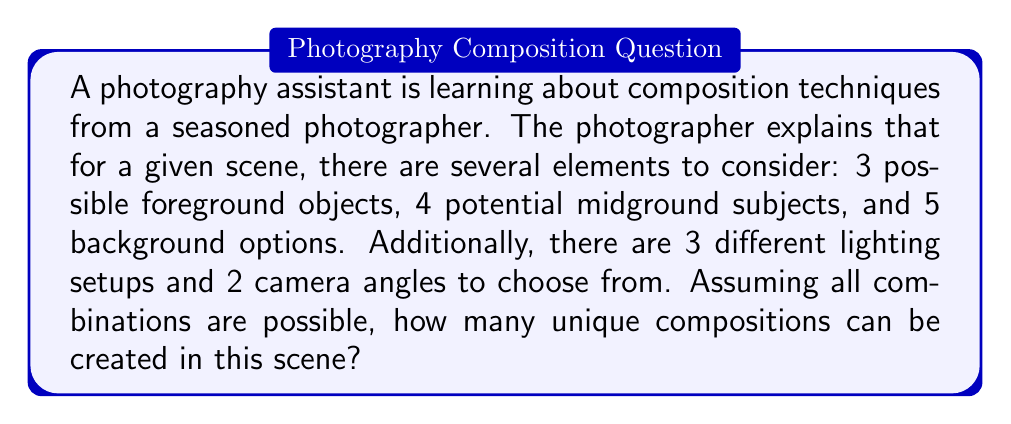What is the answer to this math problem? To solve this problem, we'll use the multiplication principle of counting. This principle states that if we have independent choices, we multiply the number of options for each choice to get the total number of possible combinations.

Let's break down the elements:

1. Foreground objects: 3 options
2. Midground subjects: 4 options
3. Background options: 5 options
4. Lighting setups: 3 options
5. Camera angles: 2 options

To calculate the total number of unique compositions, we multiply these numbers together:

$$ \text{Total compositions} = 3 \times 4 \times 5 \times 3 \times 2 $$

Let's calculate step by step:

$$ \begin{align*}
\text{Total compositions} &= 3 \times 4 \times 5 \times 3 \times 2 \\
&= 12 \times 5 \times 3 \times 2 \\
&= 60 \times 3 \times 2 \\
&= 180 \times 2 \\
&= 360
\end{align*} $$

Therefore, there are 360 possible unique compositions in this given photography scene.
Answer: 360 unique compositions 